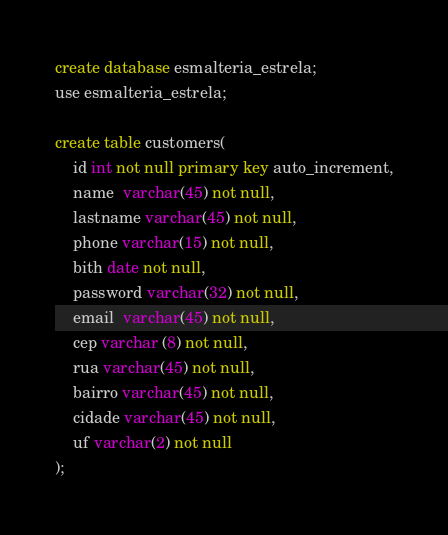<code> <loc_0><loc_0><loc_500><loc_500><_SQL_>create database esmalteria_estrela;
use esmalteria_estrela;

create table customers(
	id int not null primary key auto_increment,
    name  varchar(45) not null,
    lastname varchar(45) not null, 
	phone varchar(15) not null,
	bith date not null,
	password varchar(32) not null,
    email  varchar(45) not null,
	cep varchar (8) not null,
    rua varchar(45) not null,
    bairro varchar(45) not null,
    cidade varchar(45) not null,
    uf varchar(2) not null
);</code> 